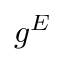<formula> <loc_0><loc_0><loc_500><loc_500>g ^ { E }</formula> 